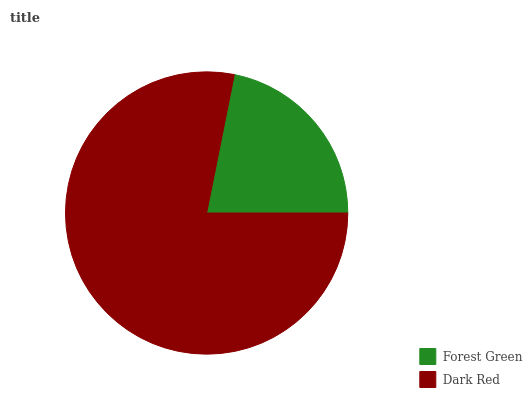Is Forest Green the minimum?
Answer yes or no. Yes. Is Dark Red the maximum?
Answer yes or no. Yes. Is Dark Red the minimum?
Answer yes or no. No. Is Dark Red greater than Forest Green?
Answer yes or no. Yes. Is Forest Green less than Dark Red?
Answer yes or no. Yes. Is Forest Green greater than Dark Red?
Answer yes or no. No. Is Dark Red less than Forest Green?
Answer yes or no. No. Is Dark Red the high median?
Answer yes or no. Yes. Is Forest Green the low median?
Answer yes or no. Yes. Is Forest Green the high median?
Answer yes or no. No. Is Dark Red the low median?
Answer yes or no. No. 